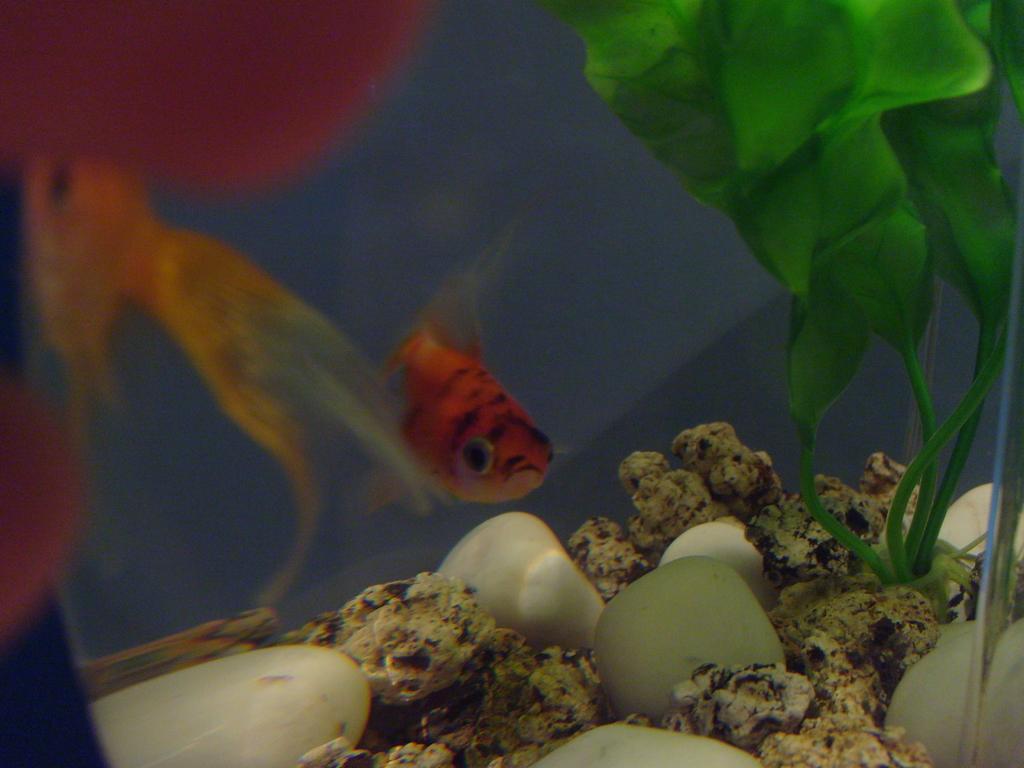In one or two sentences, can you explain what this image depicts? In the foreground of this image, there is a fish in red color in an aquarium. On bottom, we see few pebble stones and an artificial plants. On left there are few fishes. 